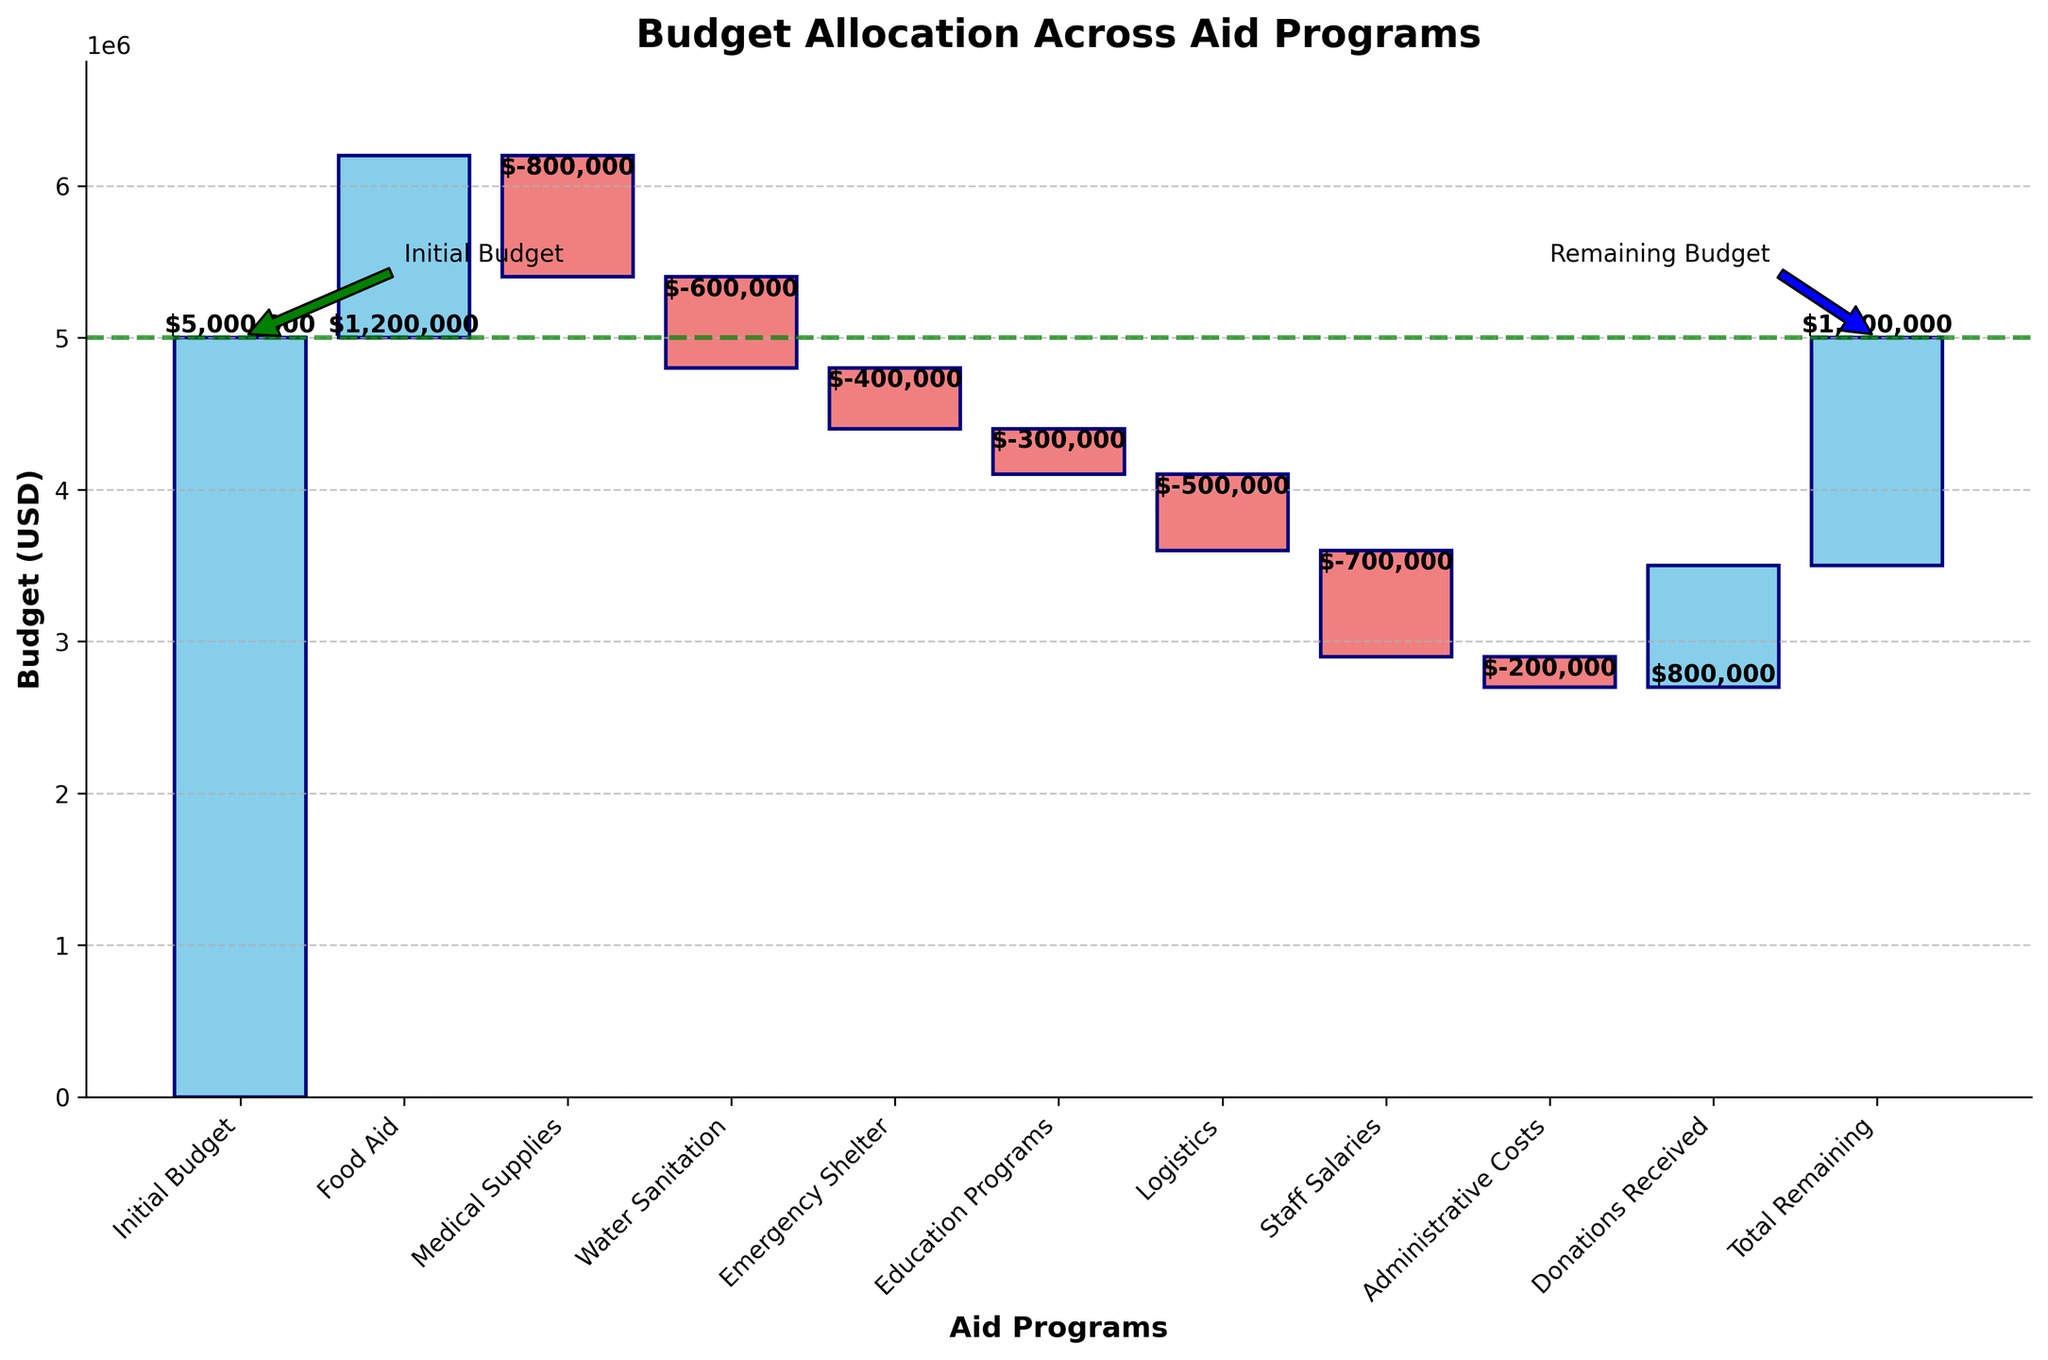What is the title of the chart? The title of the chart is displayed at the top of the figure. It reads "Budget Allocation Across Aid Programs".
Answer: Budget Allocation Across Aid Programs How much was allocated to Medical Supplies? Look at the bar labeled "Medical Supplies" in the chart. The value is shown as $-800,000.
Answer: $-800,000 Which category received the highest allocation? Compare the lengths of the bars above the axis for different categories. The longest bar above the axis is for "Food Aid" with a value of $1,200,000.
Answer: Food Aid By how much did the Emergency Shelter funding reduce the budget? Refer to the bar labeled "Emergency Shelter". The value shown is $-400,000, indicating the reduction amount.
Answer: $-400,000 What is the total remaining budget after all allocations and donations? Look at the cumulative total at the end of the waterfall chart. The label shows a remaining budget of $1,500,000.
Answer: $1,500,000 What is the cumulative impact of Food Aid and Medical Supplies on the budget? Add the values of "Food Aid" and "Medical Supplies": $1,200,000 + (-$800,000) = $400,000.
Answer: $400,000 How much did Administrative Costs reduce the budget by? Locate the bar labeled "Administrative Costs". The value shown is $-200,000.
Answer: $-200,000 Compare the funds allocated to Logistics and Staff Salaries. Which category had a higher allocation? Check the values for "Logistics" and "Staff Salaries". "Staff Salaries" has a larger negative value of $-700,000 compared to "Logistics" which is $-500,000.
Answer: Staff Salaries What percentage of the initial budget was spent on Water Sanitation? Water Sanitation value is $-600,000, and the Initial Budget is $5,000,000. Calculation: ($-600,000 / $5,000,000) * 100 = -12%.
Answer: -12% Which between Donations Received and Education Programs had a more significant impact on increasing or decreasing the budget? Compare the bar lengths and values of "Donations Received" ($800,000) with "Education Programs" ($-300,000). Donations Received increased the budget more significantly.
Answer: Donations Received 